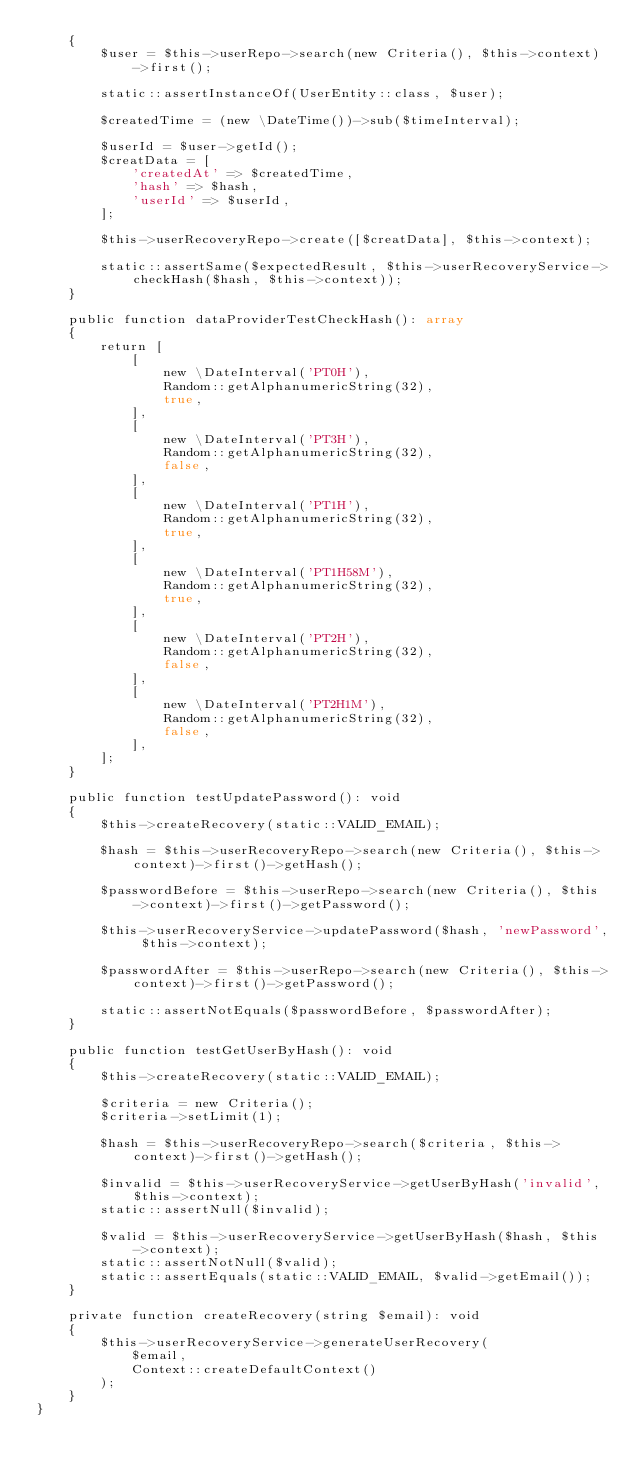Convert code to text. <code><loc_0><loc_0><loc_500><loc_500><_PHP_>    {
        $user = $this->userRepo->search(new Criteria(), $this->context)->first();

        static::assertInstanceOf(UserEntity::class, $user);

        $createdTime = (new \DateTime())->sub($timeInterval);

        $userId = $user->getId();
        $creatData = [
            'createdAt' => $createdTime,
            'hash' => $hash,
            'userId' => $userId,
        ];

        $this->userRecoveryRepo->create([$creatData], $this->context);

        static::assertSame($expectedResult, $this->userRecoveryService->checkHash($hash, $this->context));
    }

    public function dataProviderTestCheckHash(): array
    {
        return [
            [
                new \DateInterval('PT0H'),
                Random::getAlphanumericString(32),
                true,
            ],
            [
                new \DateInterval('PT3H'),
                Random::getAlphanumericString(32),
                false,
            ],
            [
                new \DateInterval('PT1H'),
                Random::getAlphanumericString(32),
                true,
            ],
            [
                new \DateInterval('PT1H58M'),
                Random::getAlphanumericString(32),
                true,
            ],
            [
                new \DateInterval('PT2H'),
                Random::getAlphanumericString(32),
                false,
            ],
            [
                new \DateInterval('PT2H1M'),
                Random::getAlphanumericString(32),
                false,
            ],
        ];
    }

    public function testUpdatePassword(): void
    {
        $this->createRecovery(static::VALID_EMAIL);

        $hash = $this->userRecoveryRepo->search(new Criteria(), $this->context)->first()->getHash();

        $passwordBefore = $this->userRepo->search(new Criteria(), $this->context)->first()->getPassword();

        $this->userRecoveryService->updatePassword($hash, 'newPassword', $this->context);

        $passwordAfter = $this->userRepo->search(new Criteria(), $this->context)->first()->getPassword();

        static::assertNotEquals($passwordBefore, $passwordAfter);
    }

    public function testGetUserByHash(): void
    {
        $this->createRecovery(static::VALID_EMAIL);

        $criteria = new Criteria();
        $criteria->setLimit(1);

        $hash = $this->userRecoveryRepo->search($criteria, $this->context)->first()->getHash();

        $invalid = $this->userRecoveryService->getUserByHash('invalid', $this->context);
        static::assertNull($invalid);

        $valid = $this->userRecoveryService->getUserByHash($hash, $this->context);
        static::assertNotNull($valid);
        static::assertEquals(static::VALID_EMAIL, $valid->getEmail());
    }

    private function createRecovery(string $email): void
    {
        $this->userRecoveryService->generateUserRecovery(
            $email,
            Context::createDefaultContext()
        );
    }
}
</code> 